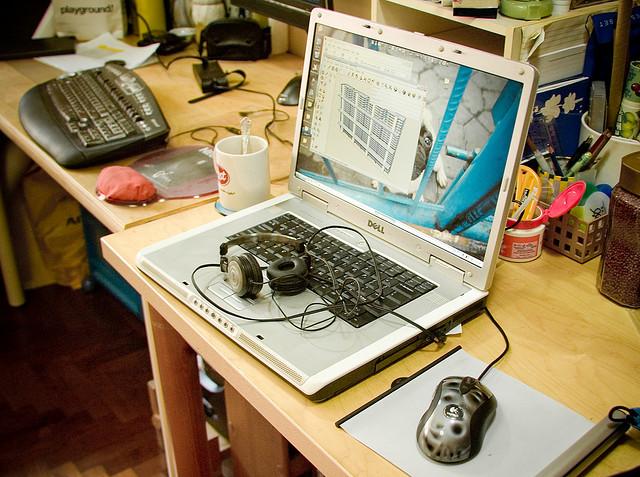What electronic device is being used to hear music?
Answer briefly. Headphones. Is the computer's owner obsessively neat?
Short answer required. No. What brand of laptop is sitting on the desk?
Quick response, please. Dell. 